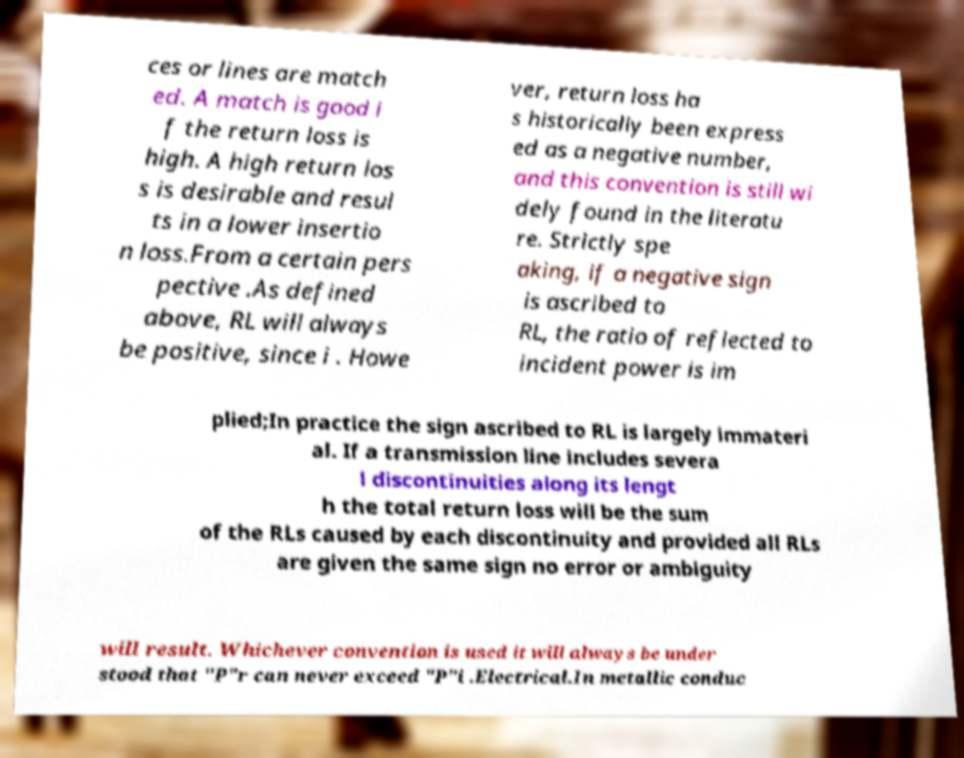Can you read and provide the text displayed in the image?This photo seems to have some interesting text. Can you extract and type it out for me? ces or lines are match ed. A match is good i f the return loss is high. A high return los s is desirable and resul ts in a lower insertio n loss.From a certain pers pective .As defined above, RL will always be positive, since i . Howe ver, return loss ha s historically been express ed as a negative number, and this convention is still wi dely found in the literatu re. Strictly spe aking, if a negative sign is ascribed to RL, the ratio of reflected to incident power is im plied;In practice the sign ascribed to RL is largely immateri al. If a transmission line includes severa l discontinuities along its lengt h the total return loss will be the sum of the RLs caused by each discontinuity and provided all RLs are given the same sign no error or ambiguity will result. Whichever convention is used it will always be under stood that "P"r can never exceed "P"i .Electrical.In metallic conduc 